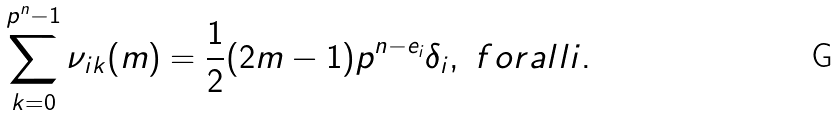<formula> <loc_0><loc_0><loc_500><loc_500>\sum _ { k = 0 } ^ { p ^ { n } - 1 } \nu _ { i k } ( m ) = \frac { 1 } { 2 } ( 2 m - 1 ) p ^ { n - e _ { i } } \delta _ { i } , \ f o r a l l i .</formula> 